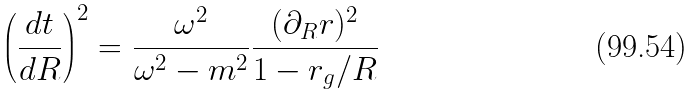<formula> <loc_0><loc_0><loc_500><loc_500>\left ( \frac { d t } { d R } \right ) ^ { 2 } = \frac { \omega ^ { 2 } } { \omega ^ { 2 } - m ^ { 2 } } \frac { ( \partial _ { R } r ) ^ { 2 } } { 1 - r _ { g } / R }</formula> 